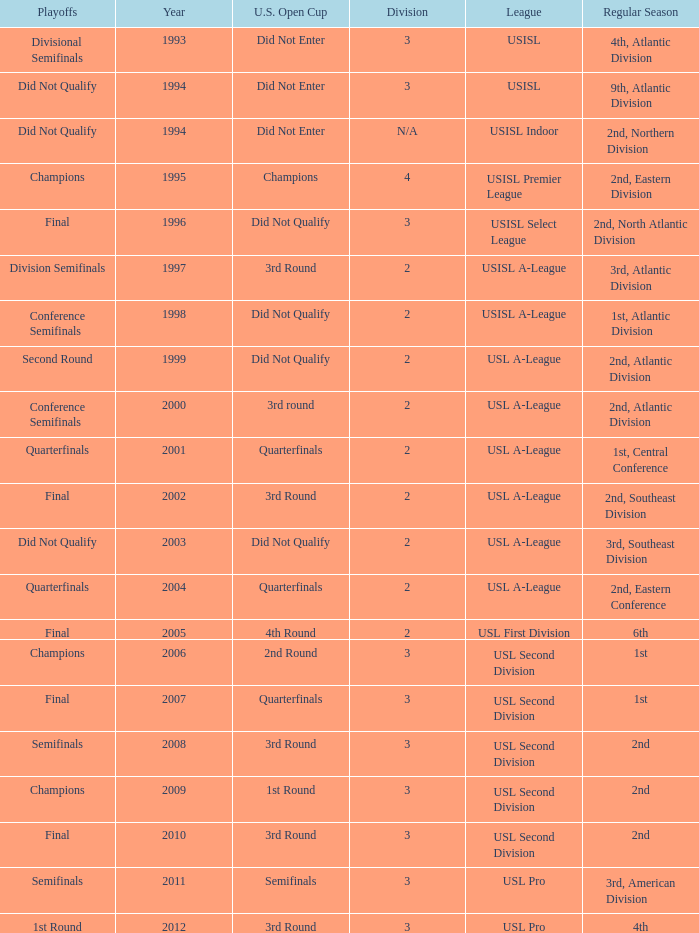What's the u.s. open cup status for regular season of 4th, atlantic division  Did Not Enter. 